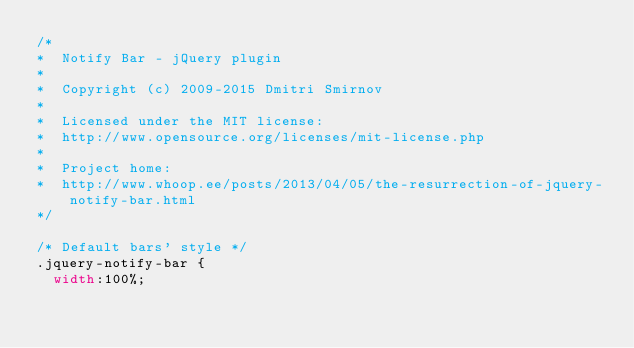Convert code to text. <code><loc_0><loc_0><loc_500><loc_500><_CSS_>/*
*  Notify Bar - jQuery plugin
*
*  Copyright (c) 2009-2015 Dmitri Smirnov
*
*  Licensed under the MIT license:
*  http://www.opensource.org/licenses/mit-license.php
*
*  Project home:
*  http://www.whoop.ee/posts/2013/04/05/the-resurrection-of-jquery-notify-bar.html
*/

/* Default bars' style */
.jquery-notify-bar {
  width:100%;</code> 